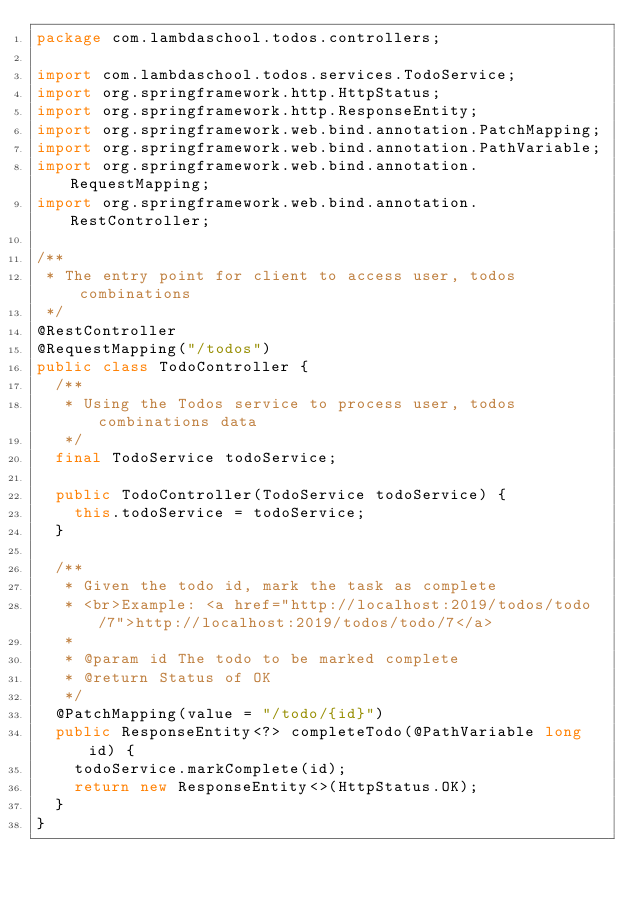<code> <loc_0><loc_0><loc_500><loc_500><_Java_>package com.lambdaschool.todos.controllers;

import com.lambdaschool.todos.services.TodoService;
import org.springframework.http.HttpStatus;
import org.springframework.http.ResponseEntity;
import org.springframework.web.bind.annotation.PatchMapping;
import org.springframework.web.bind.annotation.PathVariable;
import org.springframework.web.bind.annotation.RequestMapping;
import org.springframework.web.bind.annotation.RestController;

/**
 * The entry point for client to access user, todos combinations
 */
@RestController
@RequestMapping("/todos")
public class TodoController {
  /**
   * Using the Todos service to process user, todos combinations data
   */
  final TodoService todoService;

  public TodoController(TodoService todoService) {
    this.todoService = todoService;
  }

  /**
   * Given the todo id, mark the task as complete
   * <br>Example: <a href="http://localhost:2019/todos/todo/7">http://localhost:2019/todos/todo/7</a>
   *
   * @param id The todo to be marked complete
   * @return Status of OK
   */
  @PatchMapping(value = "/todo/{id}")
  public ResponseEntity<?> completeTodo(@PathVariable long id) {
    todoService.markComplete(id);
    return new ResponseEntity<>(HttpStatus.OK);
  }
}
</code> 